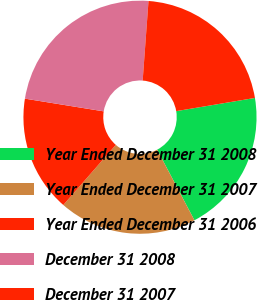<chart> <loc_0><loc_0><loc_500><loc_500><pie_chart><fcel>Year Ended December 31 2008<fcel>Year Ended December 31 2007<fcel>Year Ended December 31 2006<fcel>December 31 2008<fcel>December 31 2007<nl><fcel>19.91%<fcel>19.16%<fcel>16.12%<fcel>23.62%<fcel>21.19%<nl></chart> 